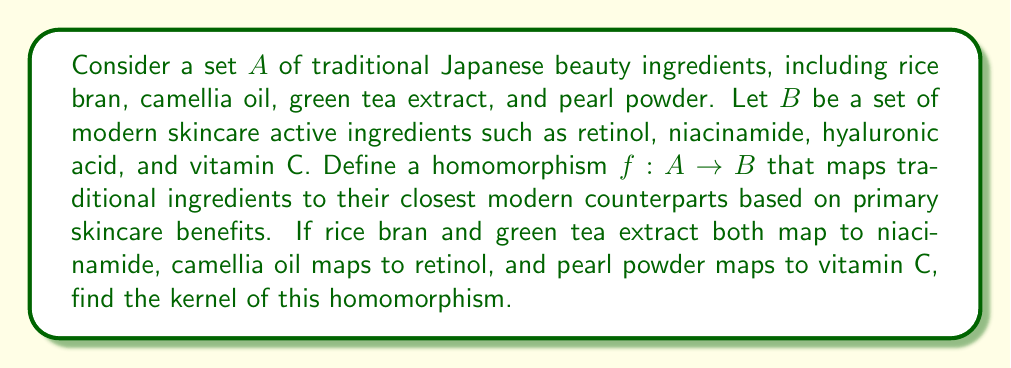Teach me how to tackle this problem. To solve this problem, we need to understand the concept of a kernel in the context of homomorphisms between sets:

1. A homomorphism $f: A \rightarrow B$ is a function that preserves the structure between two sets.

2. The kernel of a homomorphism $f: A \rightarrow B$ is the set of all elements in $A$ that map to the identity element in $B$. In the case of sets without a defined operation, we consider elements that map to the same element in $B$.

3. In this case, we need to find elements in $A$ that map to the same element in $B$.

Let's analyze the given mappings:
- $f(\text{rice bran}) = \text{niacinamide}$
- $f(\text{green tea extract}) = \text{niacinamide}$
- $f(\text{camellia oil}) = \text{retinol}$
- $f(\text{pearl powder}) = \text{vitamin C}$

We can see that rice bran and green tea extract both map to niacinamide. This means they are in the same equivalence class under this homomorphism.

The kernel of this homomorphism will consist of sets of elements from $A$ that map to the same element in $B$. In this case, we have one non-trivial set (containing more than one element) and two trivial sets:

1. $\{\text{rice bran, green tea extract}\}$
2. $\{\text{camellia oil}\}$
3. $\{\text{pearl powder}\}$

These sets form a partition of $A$, where elements in the same set are considered equivalent under the homomorphism $f$.
Answer: The kernel of the homomorphism $f: A \rightarrow B$ is:

$$\text{Ker}(f) = \{\{\text{rice bran, green tea extract}\}, \{\text{camellia oil}\}, \{\text{pearl powder}\}\}$$ 